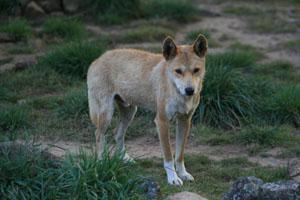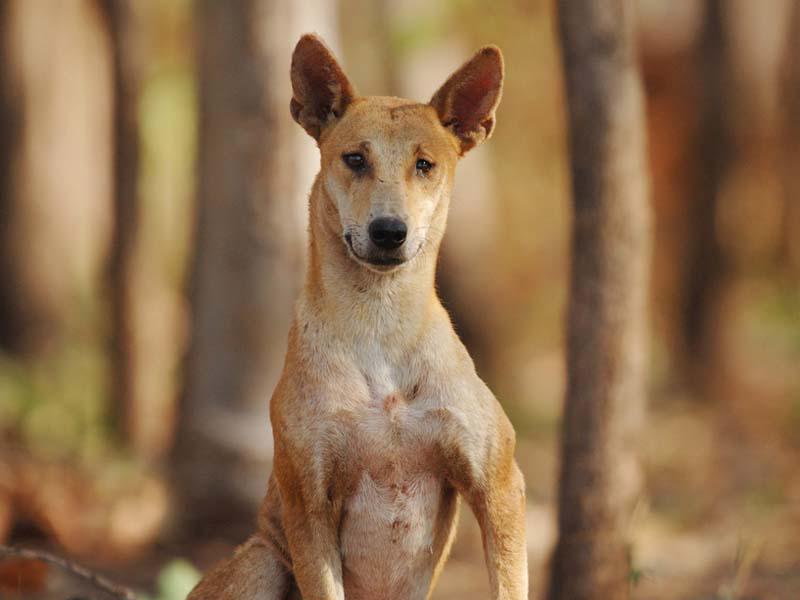The first image is the image on the left, the second image is the image on the right. Considering the images on both sides, is "Each image contains a single dingo, and one is in an upright sitting pose, while the other is standing on all fours." valid? Answer yes or no. Yes. 